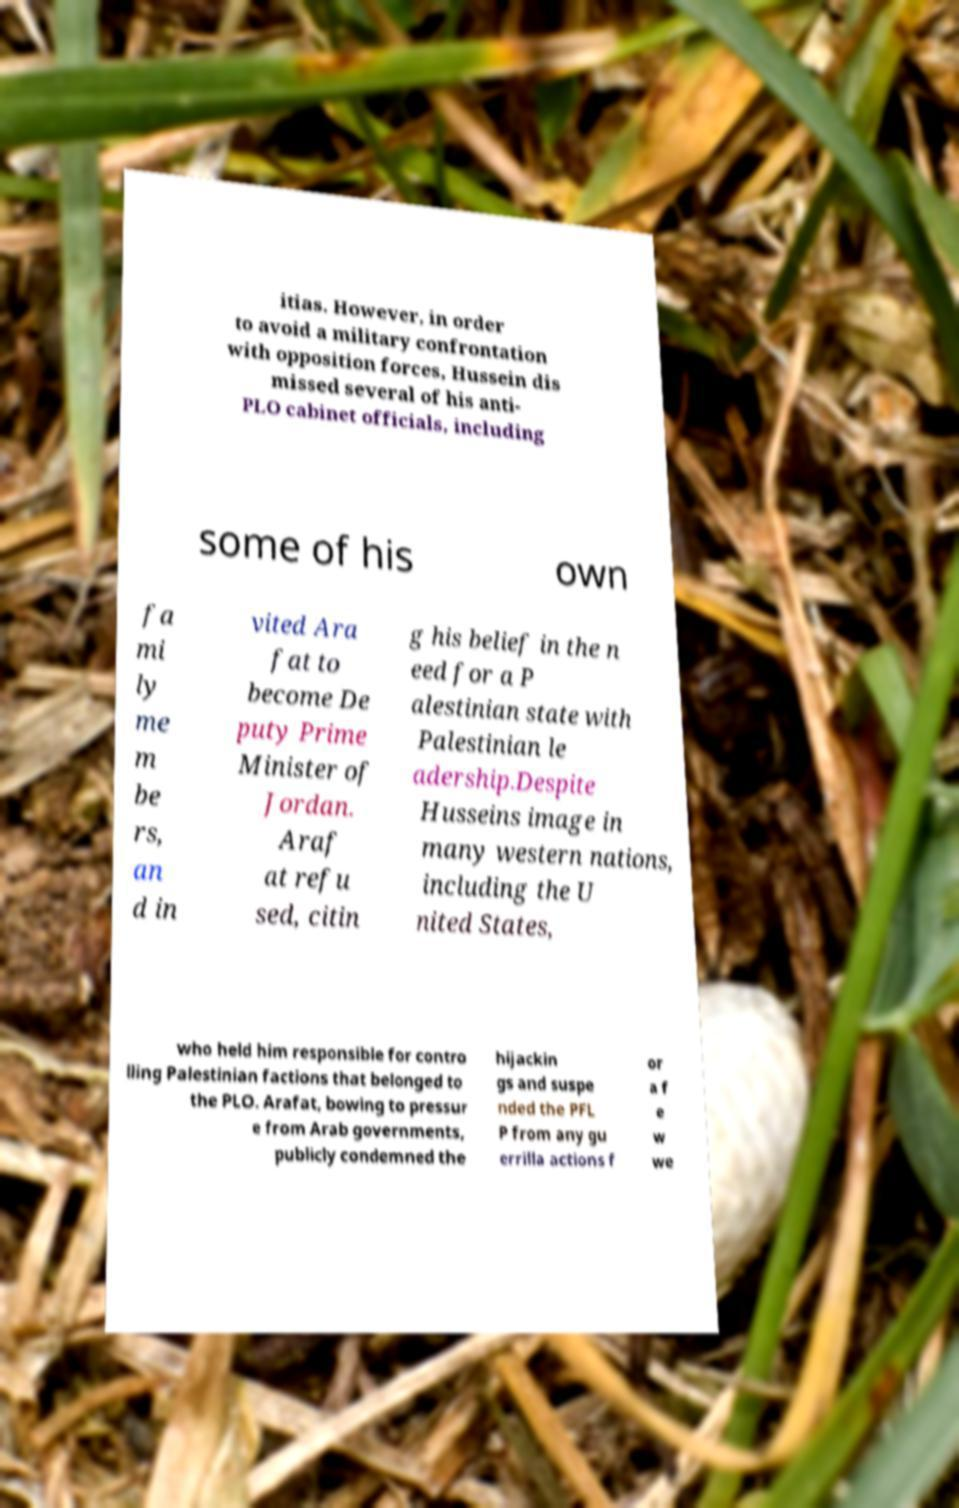Could you assist in decoding the text presented in this image and type it out clearly? itias. However, in order to avoid a military confrontation with opposition forces, Hussein dis missed several of his anti- PLO cabinet officials, including some of his own fa mi ly me m be rs, an d in vited Ara fat to become De puty Prime Minister of Jordan. Araf at refu sed, citin g his belief in the n eed for a P alestinian state with Palestinian le adership.Despite Husseins image in many western nations, including the U nited States, who held him responsible for contro lling Palestinian factions that belonged to the PLO. Arafat, bowing to pressur e from Arab governments, publicly condemned the hijackin gs and suspe nded the PFL P from any gu errilla actions f or a f e w we 